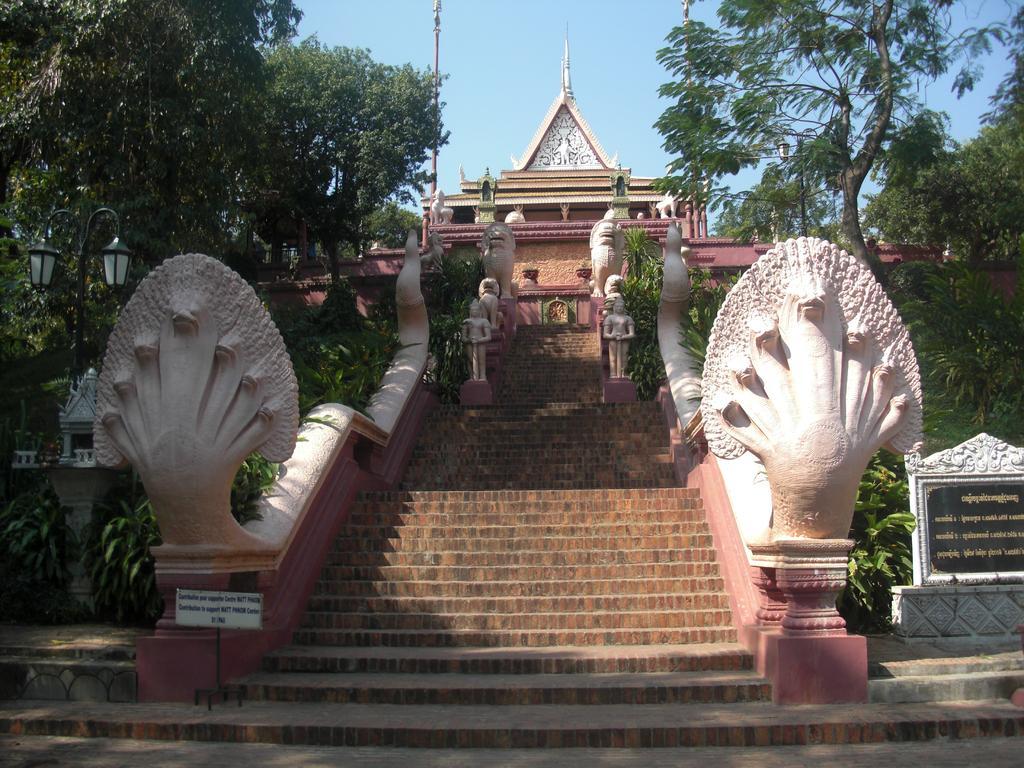In one or two sentences, can you explain what this image depicts? In the picture we can see the steps and on the either side of the steps we can see railing and some snake sculpture idols to it and in the background, we can see some historical temple construction and beside it we can see trees, plants, pole and behind we can see the sky. 